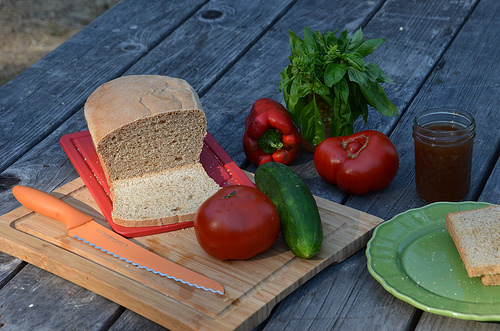<image>
Is the tomato next to the basil? No. The tomato is not positioned next to the basil. They are located in different areas of the scene. 